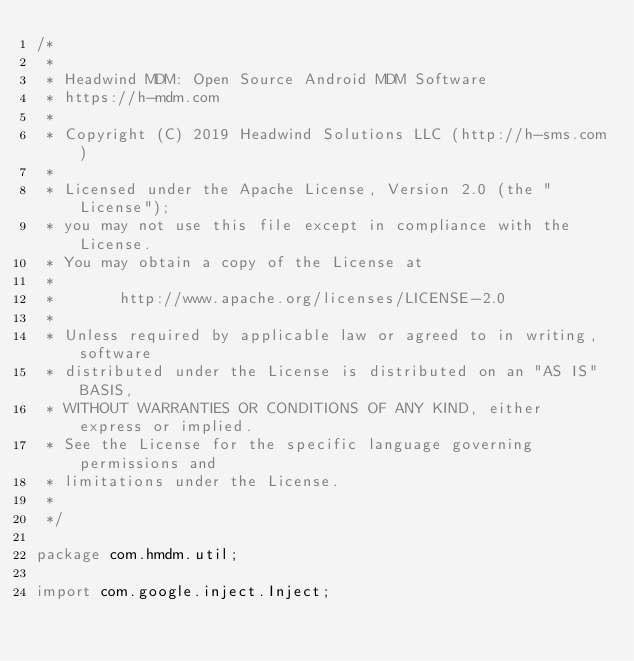<code> <loc_0><loc_0><loc_500><loc_500><_Java_>/*
 *
 * Headwind MDM: Open Source Android MDM Software
 * https://h-mdm.com
 *
 * Copyright (C) 2019 Headwind Solutions LLC (http://h-sms.com)
 *
 * Licensed under the Apache License, Version 2.0 (the "License");
 * you may not use this file except in compliance with the License.
 * You may obtain a copy of the License at
 *
 *       http://www.apache.org/licenses/LICENSE-2.0
 *
 * Unless required by applicable law or agreed to in writing, software
 * distributed under the License is distributed on an "AS IS" BASIS,
 * WITHOUT WARRANTIES OR CONDITIONS OF ANY KIND, either express or implied.
 * See the License for the specific language governing permissions and
 * limitations under the License.
 *
 */

package com.hmdm.util;

import com.google.inject.Inject;</code> 